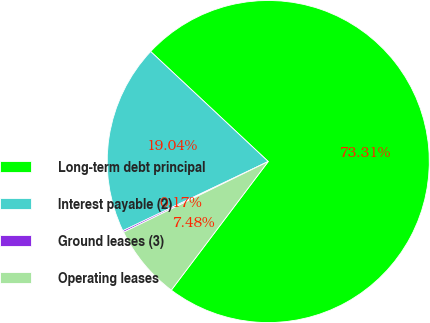<chart> <loc_0><loc_0><loc_500><loc_500><pie_chart><fcel>Long-term debt principal<fcel>Interest payable (2)<fcel>Ground leases (3)<fcel>Operating leases<nl><fcel>73.31%<fcel>19.04%<fcel>0.17%<fcel>7.48%<nl></chart> 